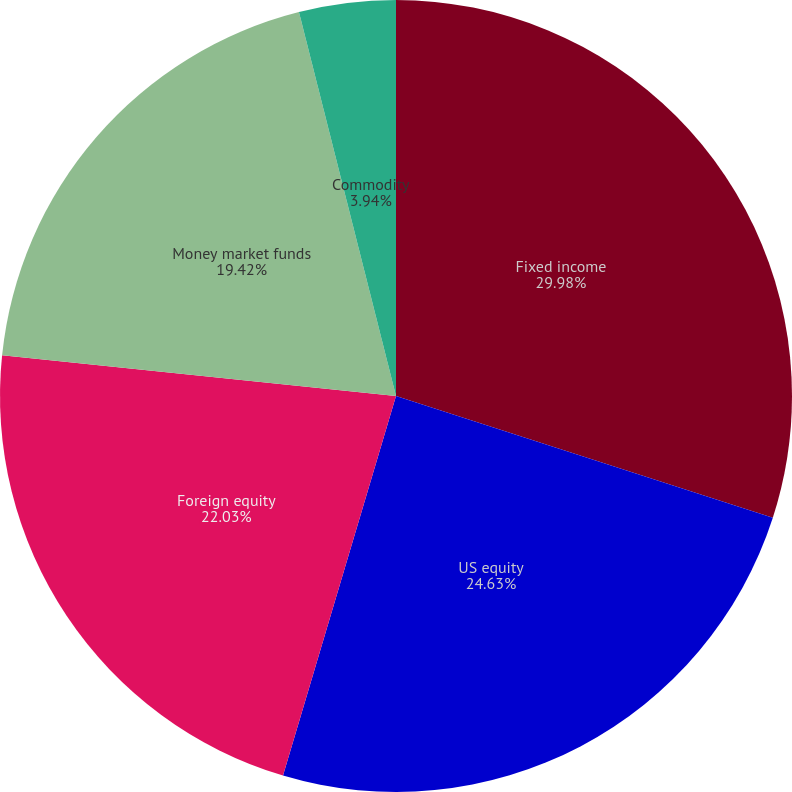Convert chart to OTSL. <chart><loc_0><loc_0><loc_500><loc_500><pie_chart><fcel>Fixed income<fcel>US equity<fcel>Foreign equity<fcel>Money market funds<fcel>Commodity<nl><fcel>29.97%<fcel>24.63%<fcel>22.03%<fcel>19.42%<fcel>3.94%<nl></chart> 